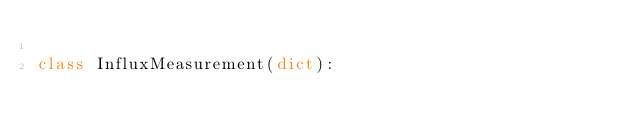Convert code to text. <code><loc_0><loc_0><loc_500><loc_500><_Python_>
class InfluxMeasurement(dict):</code> 